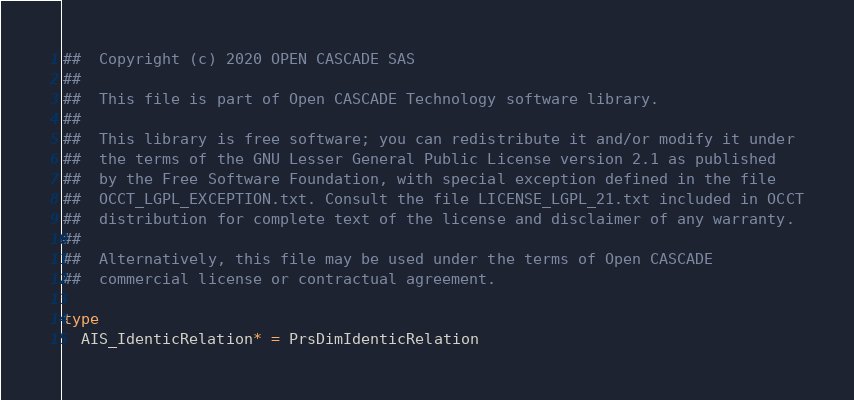<code> <loc_0><loc_0><loc_500><loc_500><_Nim_>##  Copyright (c) 2020 OPEN CASCADE SAS
##
##  This file is part of Open CASCADE Technology software library.
##
##  This library is free software; you can redistribute it and/or modify it under
##  the terms of the GNU Lesser General Public License version 2.1 as published
##  by the Free Software Foundation, with special exception defined in the file
##  OCCT_LGPL_EXCEPTION.txt. Consult the file LICENSE_LGPL_21.txt included in OCCT
##  distribution for complete text of the license and disclaimer of any warranty.
##
##  Alternatively, this file may be used under the terms of Open CASCADE
##  commercial license or contractual agreement.

type
  AIS_IdenticRelation* = PrsDimIdenticRelation
</code> 